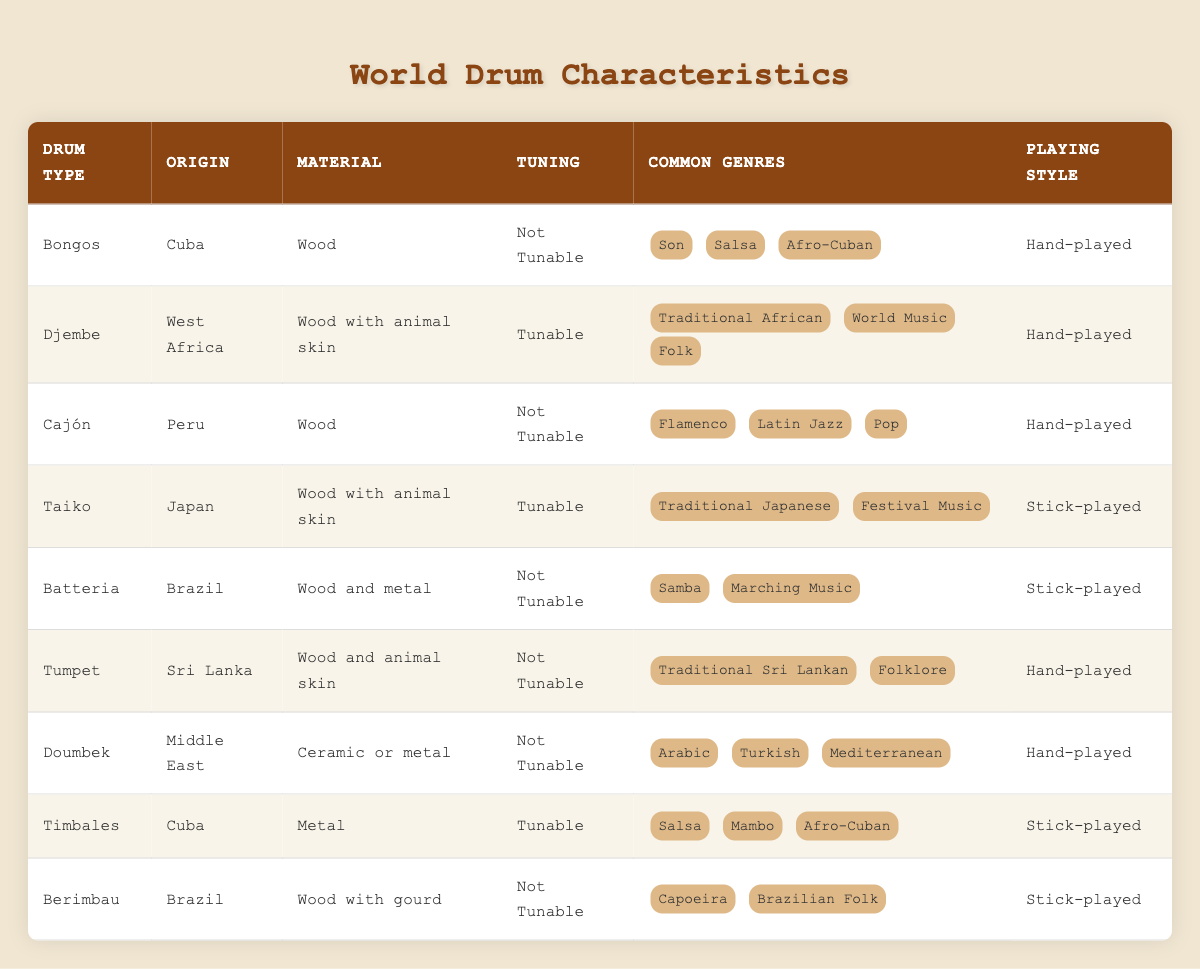What is the origin of the Djembe drum? The Djembe drum is listed with the origin as "West Africa" in the table.
Answer: West Africa Which drums are made of wood with animal skin? The Djembe and Taiko drums are listed as made of "Wood with animal skin."
Answer: Djembe, Taiko How many types of drums in the table are tunable? The tunable drums listed in the table are Djembe and Timbales, which makes a total of two.
Answer: 2 Is the Cajón drum tunable? The Cajón is specified in the table as "Not Tunable."
Answer: No What common genres are associated with the Timbales drum? The Timbales drum is associated with "Salsa," "Mambo," and "Afro-Cuban" as common genres listed in the table.
Answer: Salsa, Mambo, Afro-Cuban Which drum has a playing style that is only hand-played? The drums that have a playing style of "Hand-played" and are not stick-played are Bongos, Djembe, Cajón, Tumpet, Doumbek.
Answer: Bongos, Djembe, Cajón, Tumpet, Doumbek Name the drum type that originates from Japan and is tunable. According to the table, the drum type from Japan that is tunable is "Taiko."
Answer: Taiko How many total types of drums are listed in the table? There are a total of 9 drum types listed in the table. This is counted by checking the number of rows dedicated to drums.
Answer: 9 Which two drums are associated with Brazilian music? The drums related to Brazilian music from the table are Batteria and Berimbau. This is derived from looking at the common genres associated with each listing.
Answer: Batteria, Berimbau 